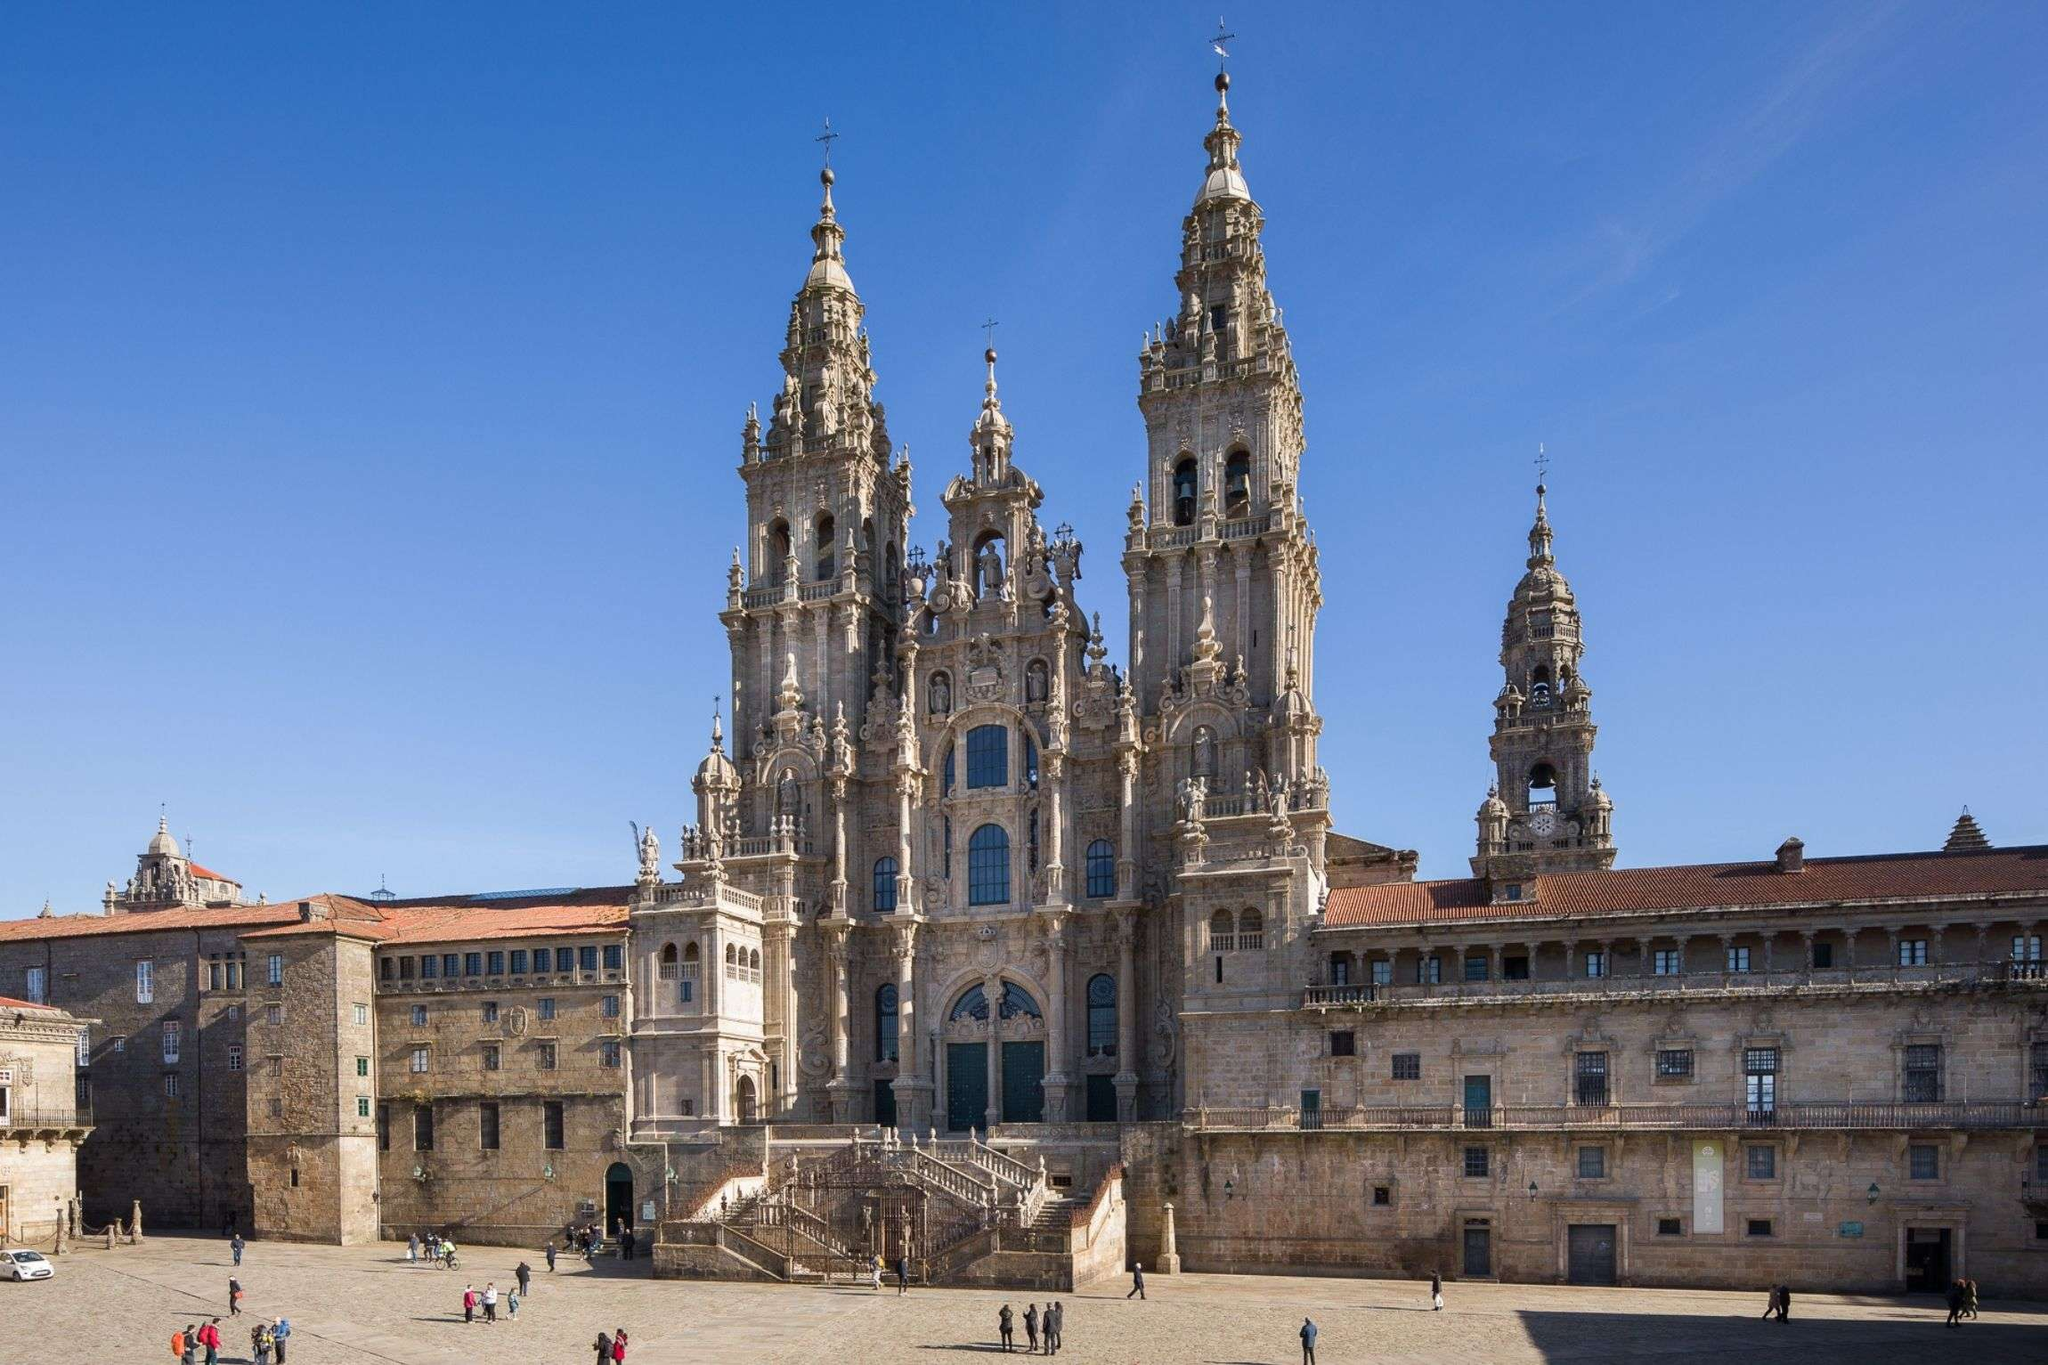Can you describe the architectural styles evident in the Cathedral Santiago De Compostela? Certainly! The Cathedral Santiago De Compostela is a mix of various architectural styles, predominantly Gothic and Baroque. The Gothic elements are evident in the pointed arches and the ribbed vaults, which are typical of the verticality and light-infused design of Gothic cathedrals. The Baroque style is prominent in the extravagant decorations, such as the intricate carvings and the dramatic, ornate spires that enhance its façade. This blend of styles gives the cathedral its distinctive and awe-inspiring appearance, symbolizing a historical amalgamation of artistic epochs. 